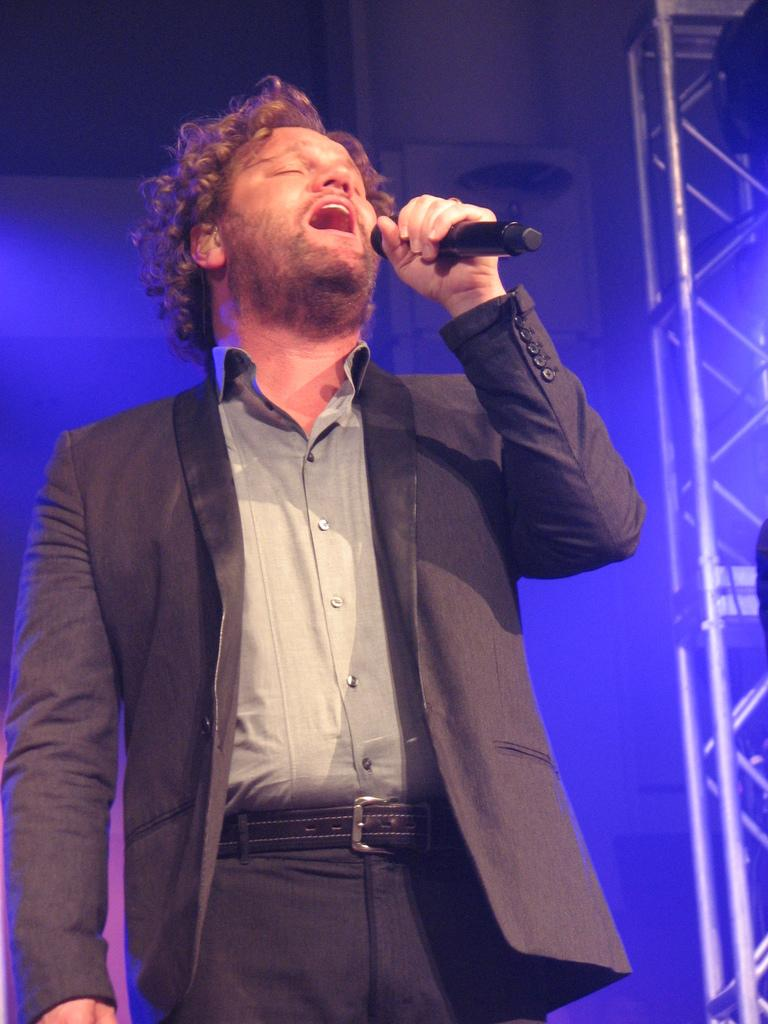Who or what is the main subject in the image? There is a person in the image. What is the person standing in front of? The person is in front of a wall. What is the person wearing? The person is wearing clothes. What is the person holding in his hand? The person is holding a mic in his hand. What can be seen on the right side of the image? There is a metal frame on the right side of the image. What type of bed is visible in the image? There is no bed present in the image. How does the person's debt affect their performance in the image? There is no mention of debt in the image, so it cannot be determined how it might affect the person's performance. 